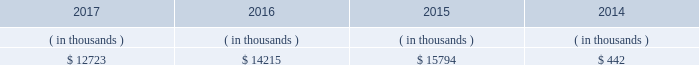The city council 2019s advisors and entergy new orleans .
In february 2018 the city council approved the settlement , which deferred cost recovery to the 2018 entergy new orleans rate case , but also stated that an adjustment for 2018-2019 ami costs can be filed in the rate case and that , for all subsequent ami costs , the mechanism to be approved in the 2018 rate case will allow for the timely recovery of such costs .
Sources of capital entergy new orleans 2019s sources to meet its capital requirements include : 2022 internally generated funds ; 2022 cash on hand ; 2022 debt and preferred membership interest issuances ; and 2022 bank financing under new or existing facilities .
Entergy new orleans may refinance , redeem , or otherwise retire debt prior to maturity , to the extent market conditions and interest rates are favorable .
Entergy new orleans 2019s receivables from the money pool were as follows as of december 31 for each of the following years. .
See note 4 to the financial statements for a description of the money pool .
Entergy new orleans has a credit facility in the amount of $ 25 million scheduled to expire in november 2018 .
The credit facility allows entergy new orleans to issue letters of credit against $ 10 million of the borrowing capacity of the facility .
As of december 31 , 2017 , there were no cash borrowings and a $ 0.8 million letter of credit was outstanding under the facility .
In addition , entergy new orleans is a party to an uncommitted letter of credit facility as a means to post collateral to support its obligations to miso . a0 as of december 31 , 2017 , a $ 1.4 million letter of credit was outstanding under entergy new orleans 2019s letter of credit a0facility .
See note 4 to the financial statements for additional discussion of the credit facilities .
Entergy new orleans obtained authorization from the ferc through october 2019 for short-term borrowings not to exceed an aggregate amount of $ 150 million at any time outstanding and long-term borrowings and securities issuances .
See note 4 to the financial statements for further discussion of entergy new orleans 2019s short-term borrowing limits .
The long-term securities issuances of entergy new orleans are limited to amounts authorized not only by the ferc , but also by the city council , and the current city council authorization extends through june 2018 .
Entergy new orleans , llc and subsidiaries management 2019s financial discussion and analysis state and local rate regulation the rates that entergy new orleans charges for electricity and natural gas significantly influence its financial position , results of operations , and liquidity .
Entergy new orleans is regulated and the rates charged to its customers are determined in regulatory proceedings .
A governmental agency , the city council , is primarily responsible for approval of the rates charged to customers .
Retail rates see 201calgiers asset transfer 201d below for discussion of the algiers asset transfer .
As a provision of the settlement agreement approved by the city council in may 2015 providing for the algiers asset transfer , it was agreed that , with limited exceptions , no action may be taken with respect to entergy new orleans 2019s base rates until rates are implemented .
As of december 31 , 2017 what was the percent of the entergy new orleans credit facility allowance for the for the issue letters of credit that was outstanding? 
Computations: (0.8 / 10)
Answer: 0.08. 